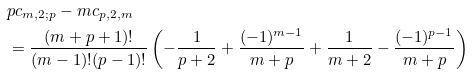<formula> <loc_0><loc_0><loc_500><loc_500>& p c _ { m , 2 ; p } - m c _ { p , 2 , m } \\ & = \frac { ( m + p + 1 ) ! } { ( m - 1 ) ! ( p - 1 ) ! } \left ( - \frac { 1 } { p + 2 } + \frac { ( - 1 ) ^ { m - 1 } } { m + p } + \frac { 1 } { m + 2 } - \frac { ( - 1 ) ^ { p - 1 } } { m + p } \right )</formula> 